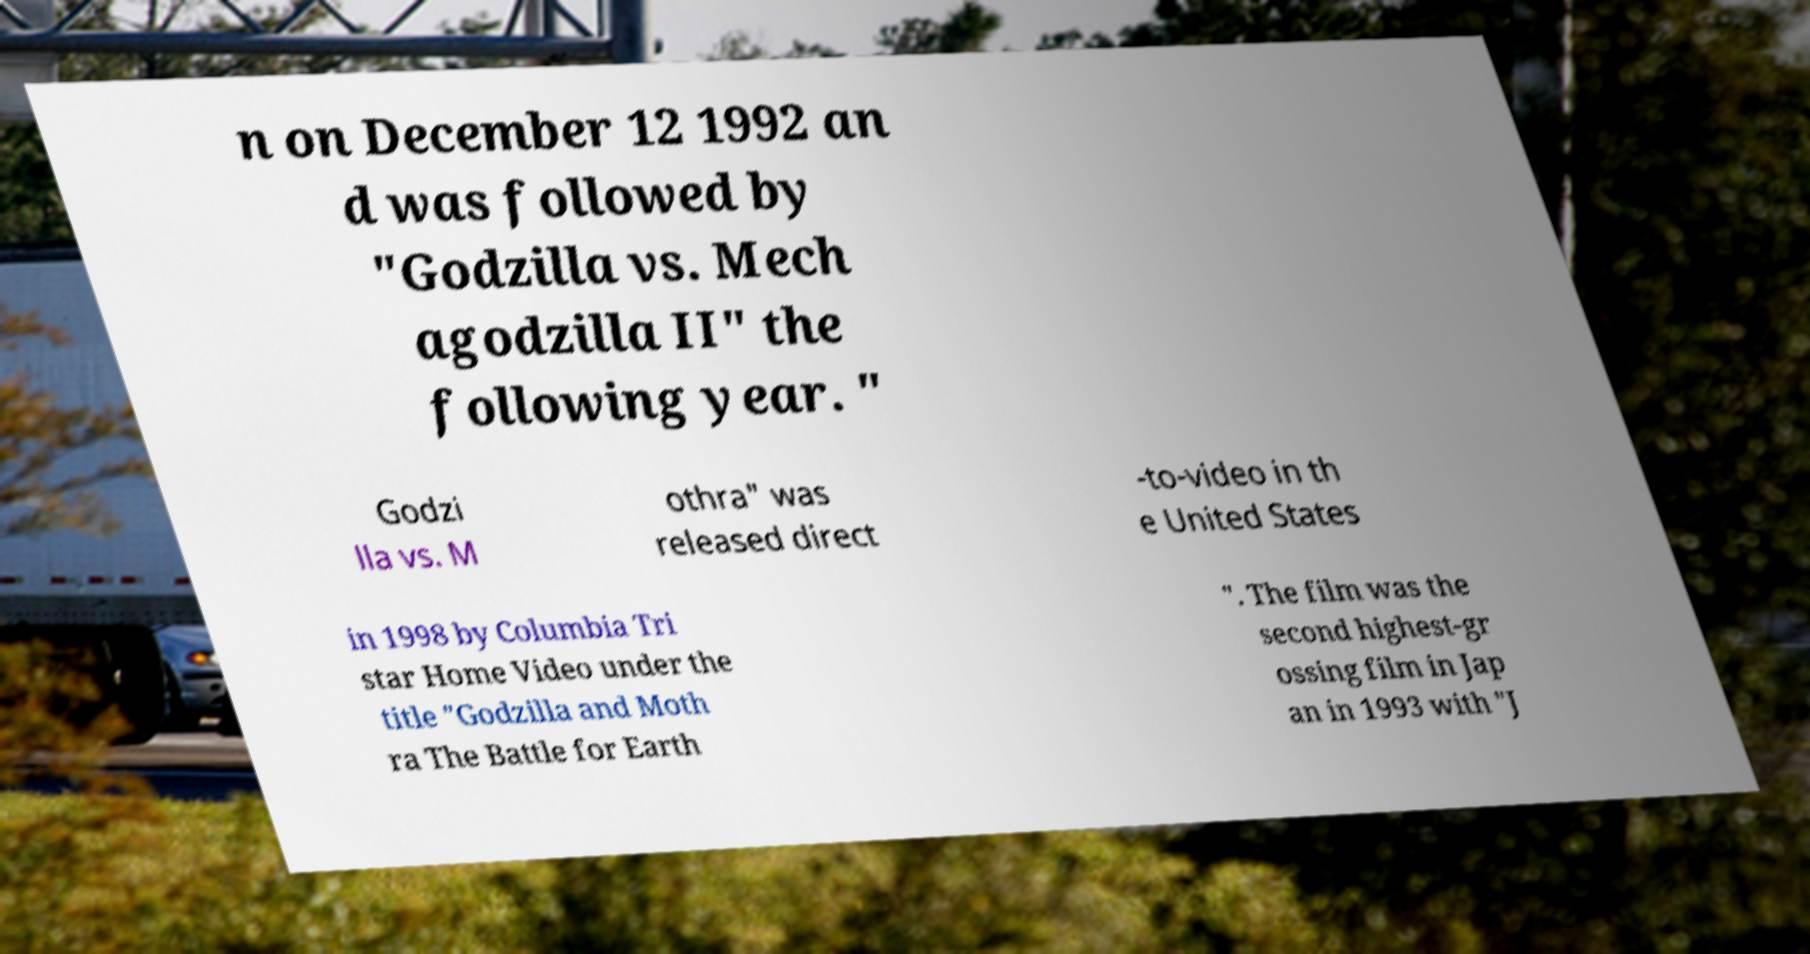Please read and relay the text visible in this image. What does it say? n on December 12 1992 an d was followed by "Godzilla vs. Mech agodzilla II" the following year. " Godzi lla vs. M othra" was released direct -to-video in th e United States in 1998 by Columbia Tri star Home Video under the title "Godzilla and Moth ra The Battle for Earth ". The film was the second highest-gr ossing film in Jap an in 1993 with "J 